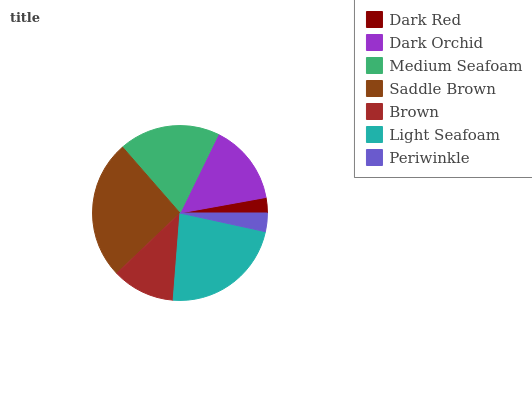Is Dark Red the minimum?
Answer yes or no. Yes. Is Saddle Brown the maximum?
Answer yes or no. Yes. Is Dark Orchid the minimum?
Answer yes or no. No. Is Dark Orchid the maximum?
Answer yes or no. No. Is Dark Orchid greater than Dark Red?
Answer yes or no. Yes. Is Dark Red less than Dark Orchid?
Answer yes or no. Yes. Is Dark Red greater than Dark Orchid?
Answer yes or no. No. Is Dark Orchid less than Dark Red?
Answer yes or no. No. Is Dark Orchid the high median?
Answer yes or no. Yes. Is Dark Orchid the low median?
Answer yes or no. Yes. Is Brown the high median?
Answer yes or no. No. Is Light Seafoam the low median?
Answer yes or no. No. 